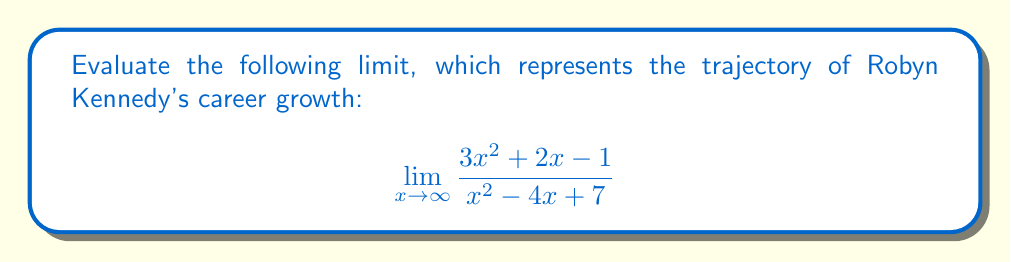Solve this math problem. To evaluate this limit, we'll follow these steps:

1) First, we identify the highest degree terms in both the numerator and denominator:
   Numerator: $3x^2$
   Denominator: $x^2$

2) We divide both the numerator and denominator by the highest degree term in the denominator, which is $x^2$:

   $$\lim_{x \to \infty} \frac{3x^2 + 2x - 1}{x^2 - 4x + 7} = \lim_{x \to \infty} \frac{3x^2/x^2 + 2x/x^2 - 1/x^2}{x^2/x^2 - 4x/x^2 + 7/x^2}$$

3) Simplify:

   $$\lim_{x \to \infty} \frac{3 + 2/x - 1/x^2}{1 - 4/x + 7/x^2}$$

4) As $x$ approaches infinity, $1/x$ and $1/x^2$ approach 0:

   $$\lim_{x \to \infty} \frac{3 + 0 - 0}{1 - 0 + 0} = \frac{3}{1} = 3$$

Therefore, the limit of the function as $x$ approaches infinity is 3.
Answer: $3$ 